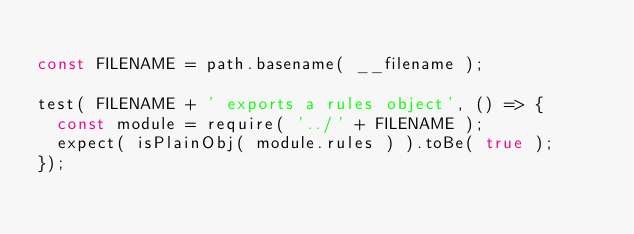<code> <loc_0><loc_0><loc_500><loc_500><_JavaScript_>
const FILENAME = path.basename( __filename );

test( FILENAME + ' exports a rules object', () => {
  const module = require( '../' + FILENAME );
  expect( isPlainObj( module.rules ) ).toBe( true );
});
</code> 